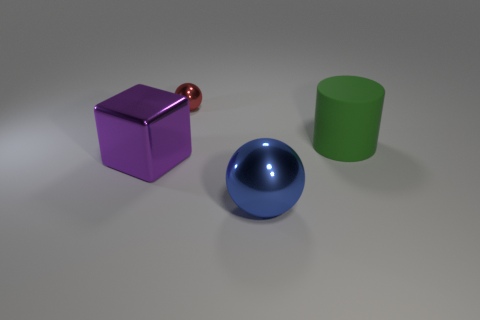How many objects are either balls in front of the large green rubber cylinder or gray rubber spheres?
Your answer should be very brief. 1. Is the number of purple shiny things on the left side of the cylinder greater than the number of big metal objects that are behind the tiny metallic thing?
Your response must be concise. Yes. There is a rubber cylinder; is its size the same as the sphere behind the big blue metal thing?
Make the answer very short. No. How many cylinders are either green objects or tiny red things?
Your answer should be very brief. 1. The blue sphere that is made of the same material as the big cube is what size?
Ensure brevity in your answer.  Large. Does the metallic thing behind the rubber cylinder have the same size as the thing right of the large blue ball?
Offer a very short reply. No. How many things are large balls or red metallic cylinders?
Your answer should be compact. 1. The blue metallic object is what shape?
Make the answer very short. Sphere. What is the size of the other blue thing that is the same shape as the tiny thing?
Provide a succinct answer. Large. Are there any other things that have the same material as the purple thing?
Make the answer very short. Yes. 